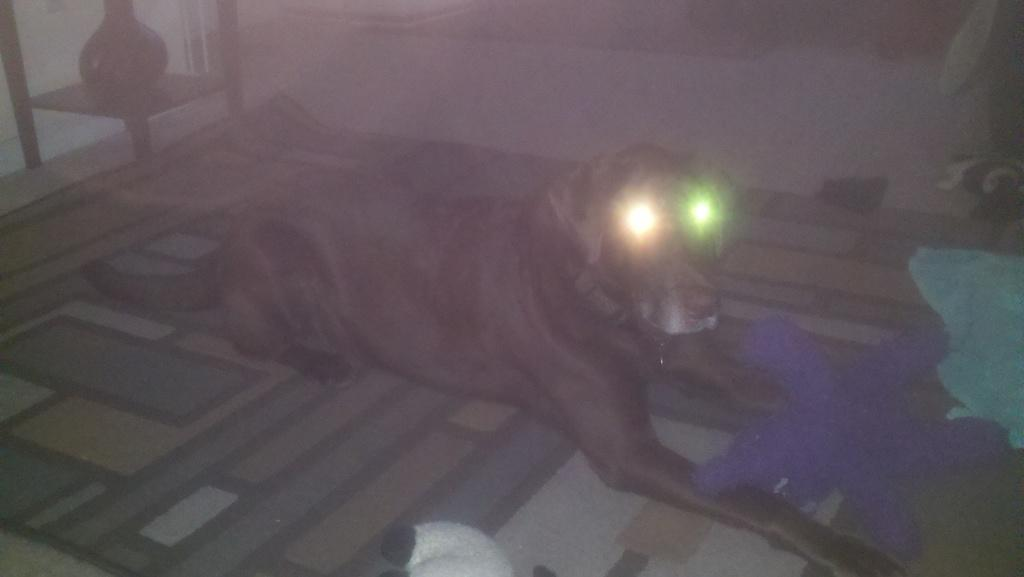What type of animal is in the image? There is a black dog in the image. Where is the dog located? The dog is sitting on a floor mat. What is unique about the dog's eyes? The dog's eyes are shining like lights. What type of stocking is the dog wearing on its legs in the image? There is no stocking present on the dog's legs in the image. 